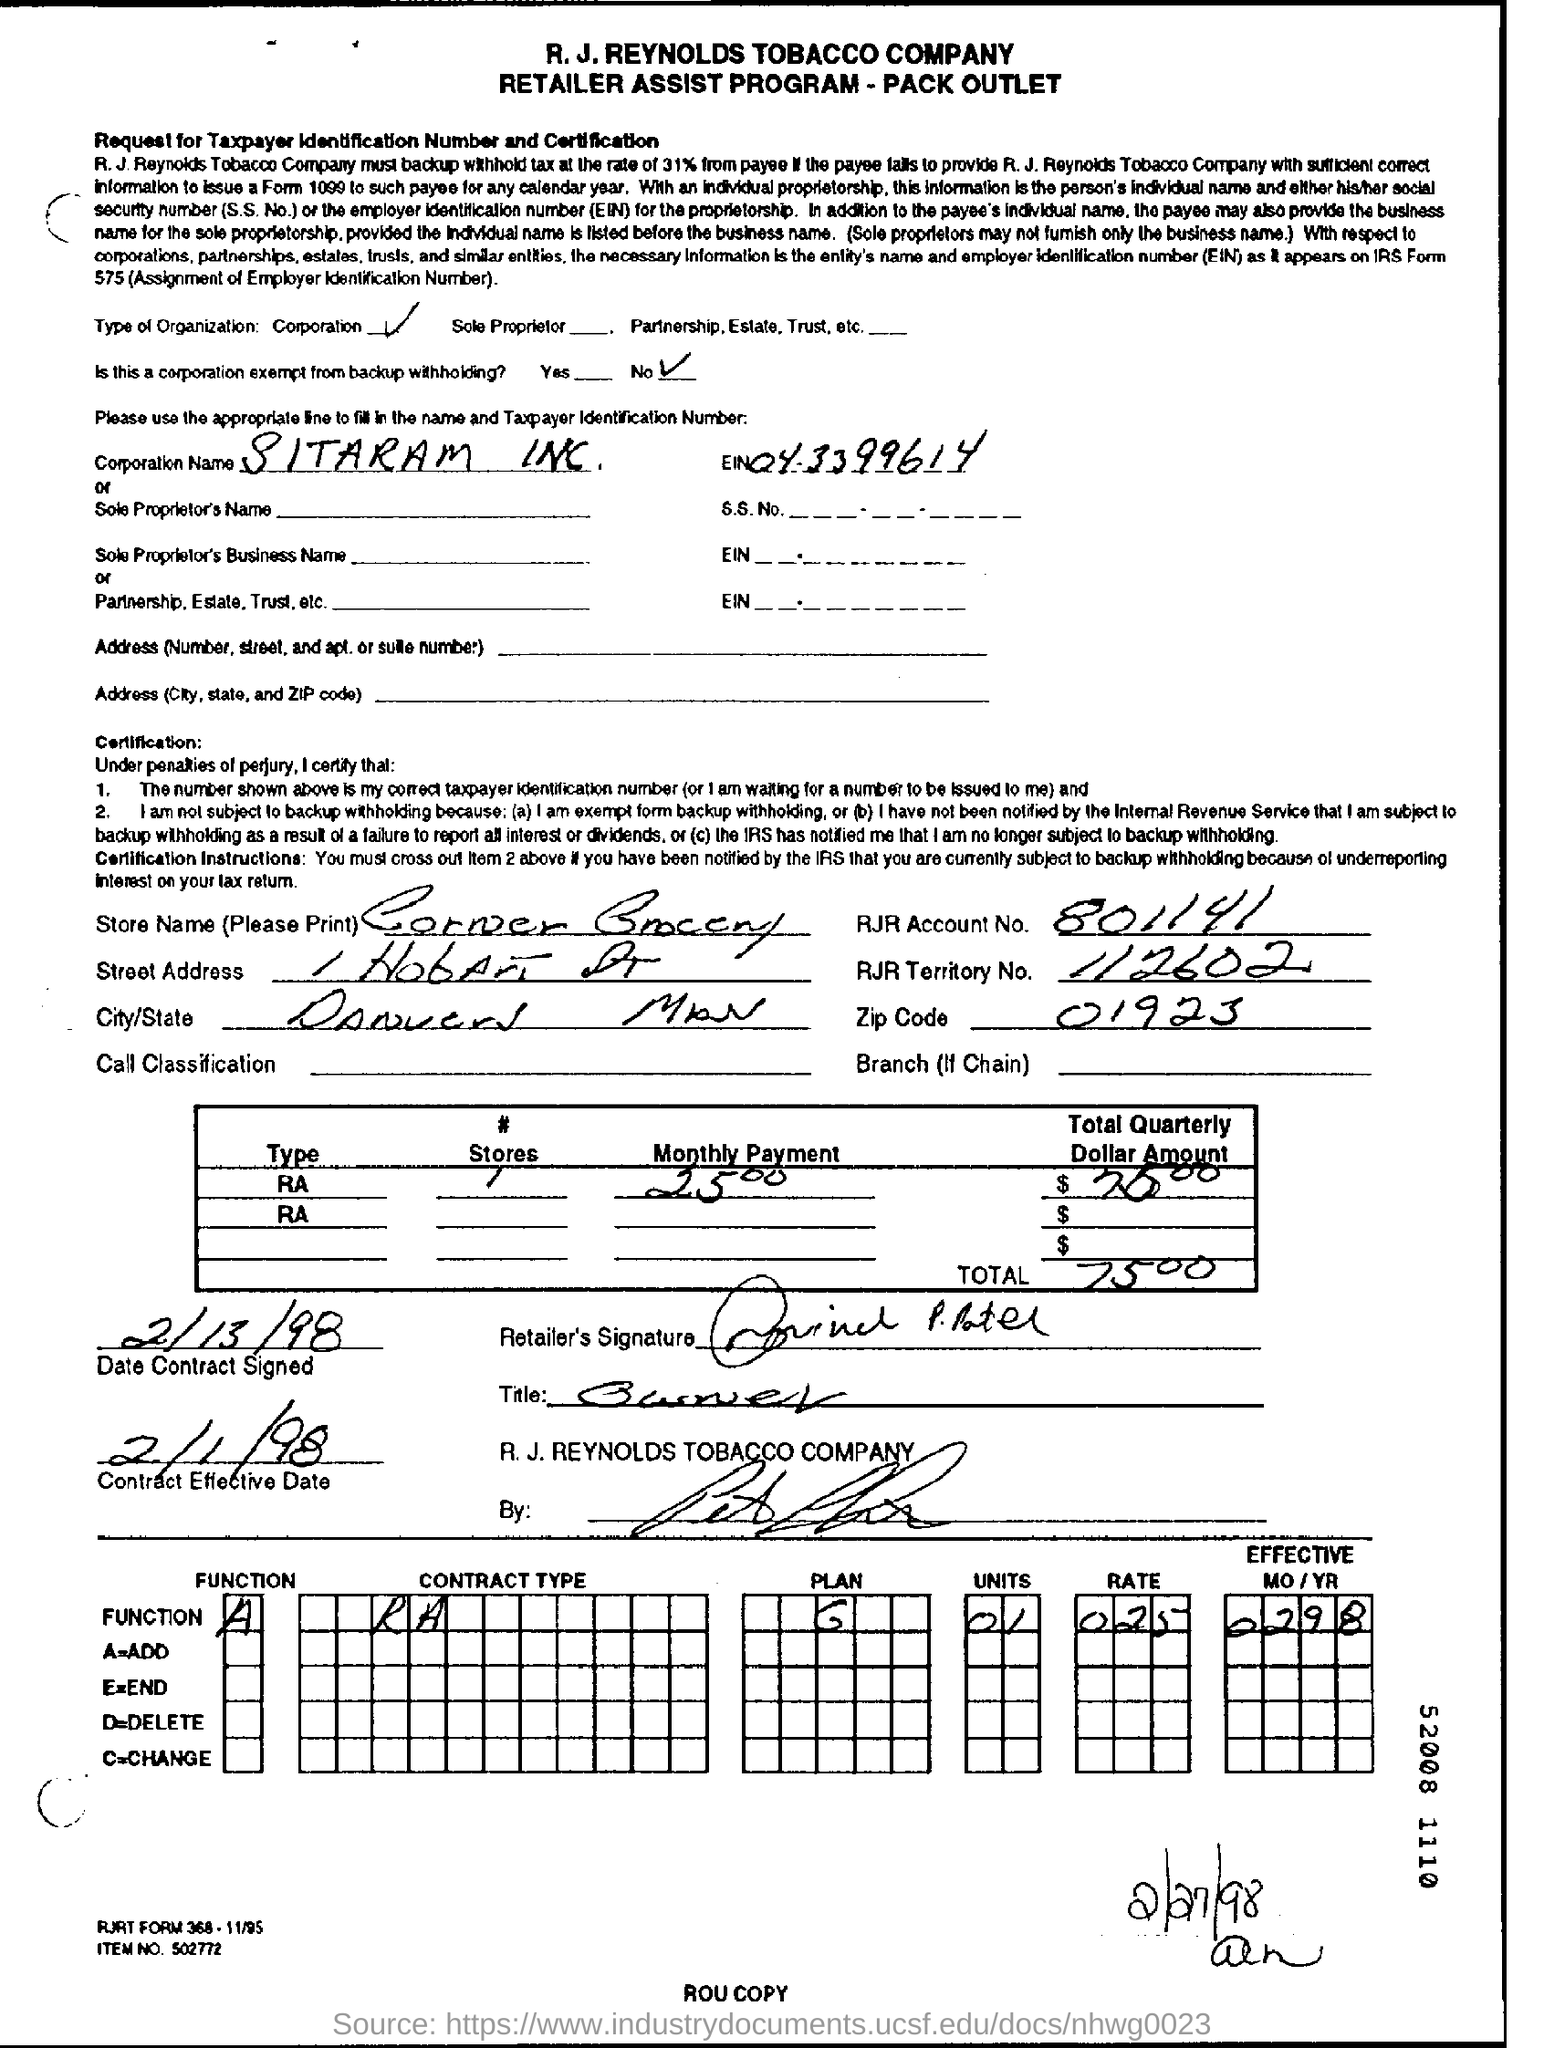What is the type of organization?
Give a very brief answer. Corporation. Is this a corporation exempt from backup withholding?
Make the answer very short. No. What is the corporation name?
Offer a terse response. SITARAM INC. What is the EIN for Sitaram inc.
Ensure brevity in your answer.  04.3399614. What is the store name?
Give a very brief answer. Corner Grocery. What is the RJR account number?
Your answer should be very brief. 801141. What is the RJR Territory No.?
Give a very brief answer. 112602. What is the total Quaterly Dollar Amount?
Your response must be concise. 7500. 